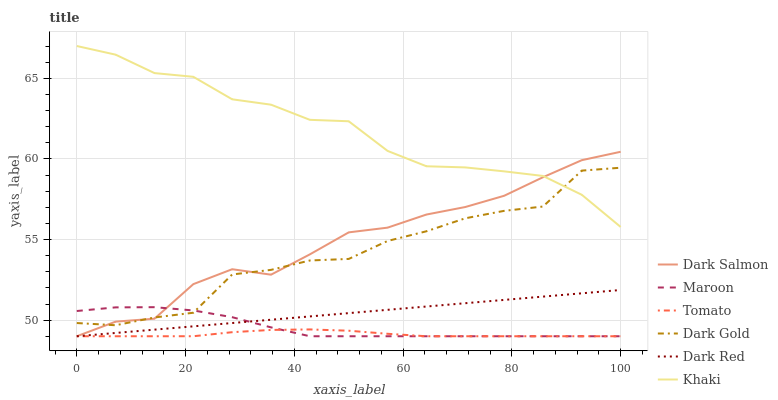Does Tomato have the minimum area under the curve?
Answer yes or no. Yes. Does Khaki have the maximum area under the curve?
Answer yes or no. Yes. Does Dark Gold have the minimum area under the curve?
Answer yes or no. No. Does Dark Gold have the maximum area under the curve?
Answer yes or no. No. Is Dark Red the smoothest?
Answer yes or no. Yes. Is Dark Gold the roughest?
Answer yes or no. Yes. Is Khaki the smoothest?
Answer yes or no. No. Is Khaki the roughest?
Answer yes or no. No. Does Tomato have the lowest value?
Answer yes or no. Yes. Does Dark Gold have the lowest value?
Answer yes or no. No. Does Khaki have the highest value?
Answer yes or no. Yes. Does Dark Gold have the highest value?
Answer yes or no. No. Is Maroon less than Khaki?
Answer yes or no. Yes. Is Khaki greater than Tomato?
Answer yes or no. Yes. Does Maroon intersect Dark Red?
Answer yes or no. Yes. Is Maroon less than Dark Red?
Answer yes or no. No. Is Maroon greater than Dark Red?
Answer yes or no. No. Does Maroon intersect Khaki?
Answer yes or no. No. 